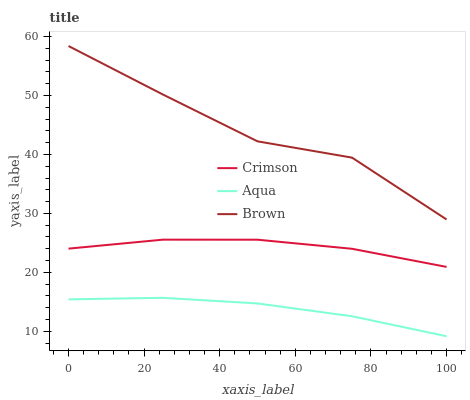Does Aqua have the minimum area under the curve?
Answer yes or no. Yes. Does Brown have the maximum area under the curve?
Answer yes or no. Yes. Does Brown have the minimum area under the curve?
Answer yes or no. No. Does Aqua have the maximum area under the curve?
Answer yes or no. No. Is Aqua the smoothest?
Answer yes or no. Yes. Is Brown the roughest?
Answer yes or no. Yes. Is Brown the smoothest?
Answer yes or no. No. Is Aqua the roughest?
Answer yes or no. No. Does Aqua have the lowest value?
Answer yes or no. Yes. Does Brown have the lowest value?
Answer yes or no. No. Does Brown have the highest value?
Answer yes or no. Yes. Does Aqua have the highest value?
Answer yes or no. No. Is Crimson less than Brown?
Answer yes or no. Yes. Is Crimson greater than Aqua?
Answer yes or no. Yes. Does Crimson intersect Brown?
Answer yes or no. No. 